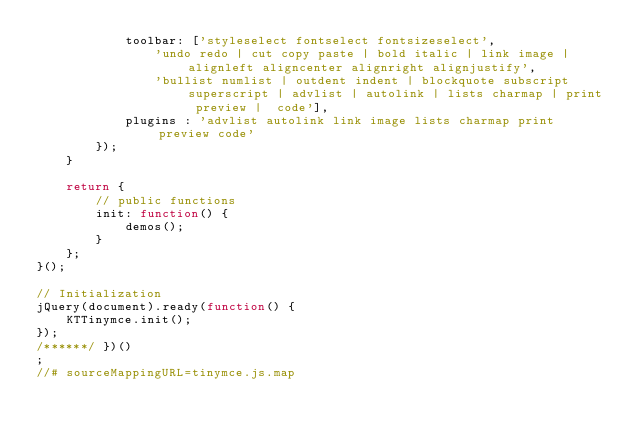Convert code to text. <code><loc_0><loc_0><loc_500><loc_500><_JavaScript_>            toolbar: ['styleselect fontselect fontsizeselect',
                'undo redo | cut copy paste | bold italic | link image | alignleft aligncenter alignright alignjustify',
                'bullist numlist | outdent indent | blockquote subscript superscript | advlist | autolink | lists charmap | print preview |  code'], 
            plugins : 'advlist autolink link image lists charmap print preview code'
        });       
    }

    return {
        // public functions
        init: function() {
            demos(); 
        }
    };
}();

// Initialization
jQuery(document).ready(function() {
    KTTinymce.init();
});
/******/ })()
;
//# sourceMappingURL=tinymce.js.map</code> 